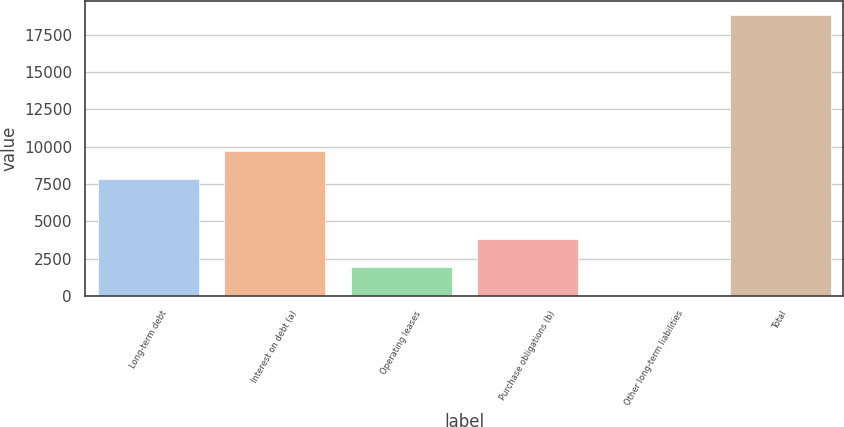Convert chart. <chart><loc_0><loc_0><loc_500><loc_500><bar_chart><fcel>Long-term debt<fcel>Interest on debt (a)<fcel>Operating leases<fcel>Purchase obligations (b)<fcel>Other long-term liabilities<fcel>Total<nl><fcel>7871<fcel>9746<fcel>1929<fcel>3804<fcel>54<fcel>18804<nl></chart> 